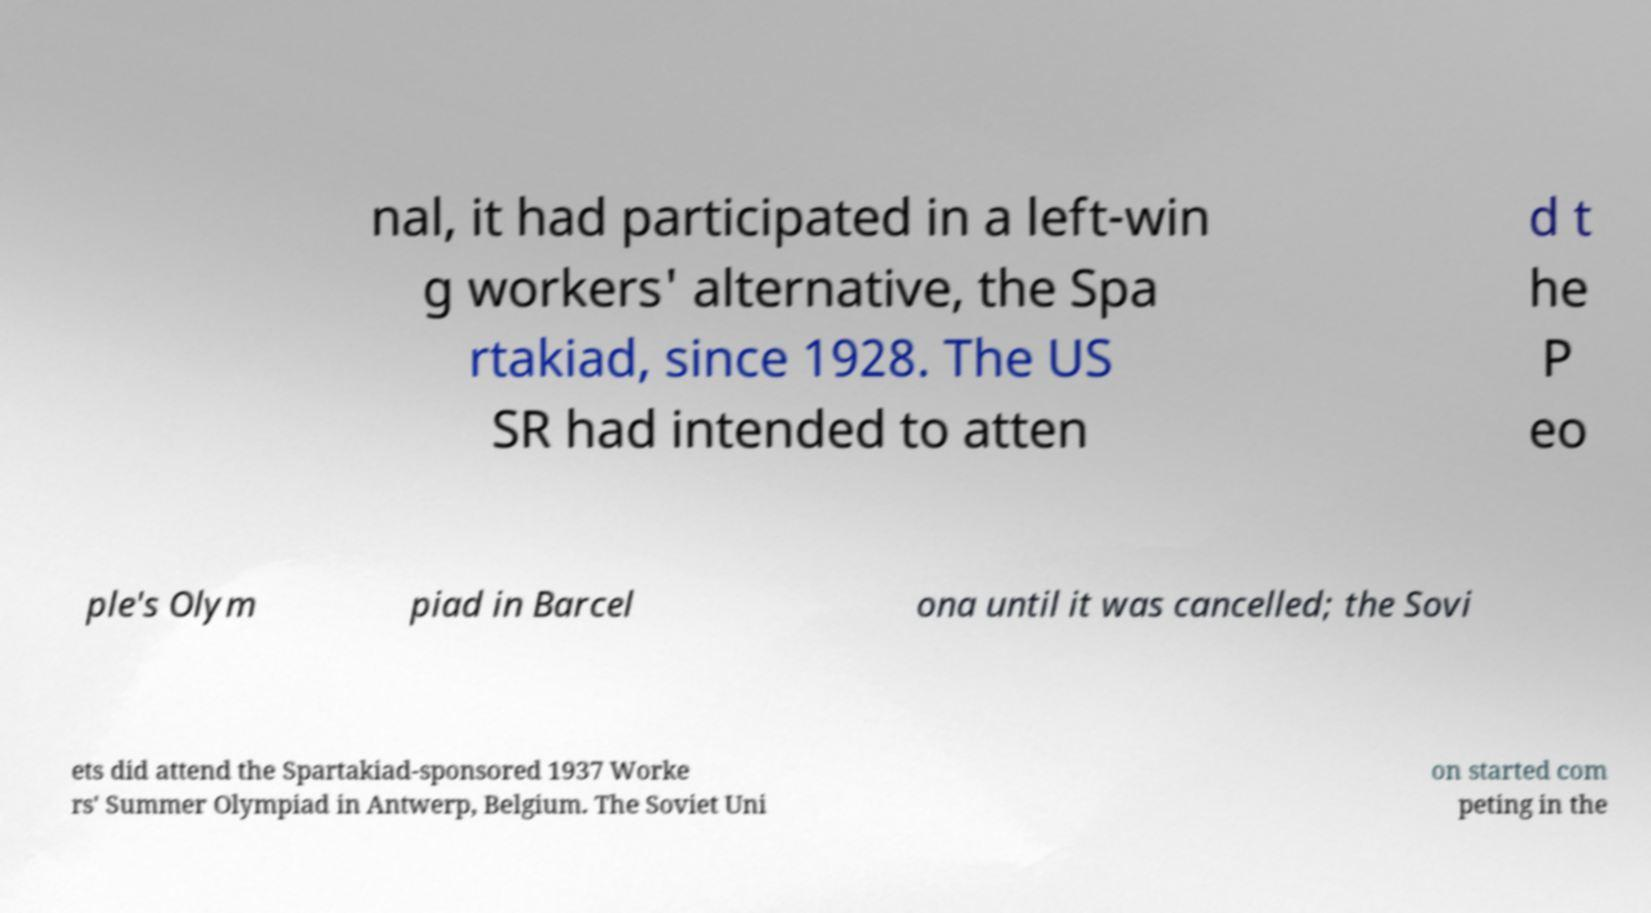Could you assist in decoding the text presented in this image and type it out clearly? nal, it had participated in a left-win g workers' alternative, the Spa rtakiad, since 1928. The US SR had intended to atten d t he P eo ple's Olym piad in Barcel ona until it was cancelled; the Sovi ets did attend the Spartakiad-sponsored 1937 Worke rs' Summer Olympiad in Antwerp, Belgium. The Soviet Uni on started com peting in the 